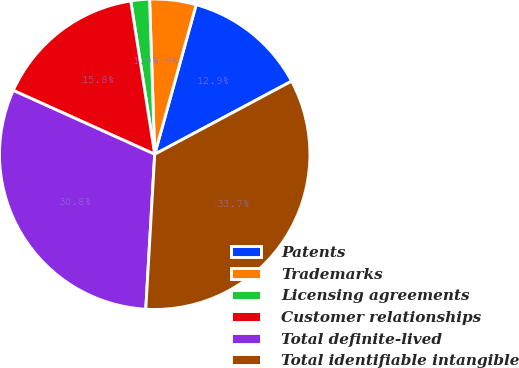<chart> <loc_0><loc_0><loc_500><loc_500><pie_chart><fcel>Patents<fcel>Trademarks<fcel>Licensing agreements<fcel>Customer relationships<fcel>Total definite-lived<fcel>Total identifiable intangible<nl><fcel>12.89%<fcel>4.83%<fcel>1.94%<fcel>15.78%<fcel>30.83%<fcel>33.72%<nl></chart> 